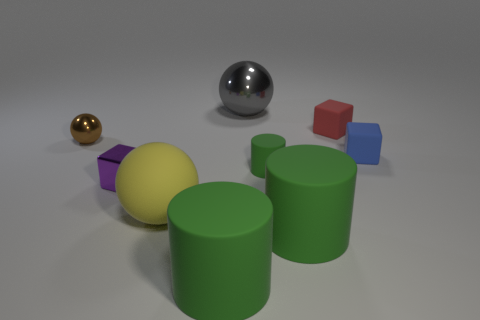Subtract all balls. How many objects are left? 6 Subtract 0 yellow cylinders. How many objects are left? 9 Subtract all gray rubber spheres. Subtract all tiny green objects. How many objects are left? 8 Add 6 red matte things. How many red matte things are left? 7 Add 3 tiny green rubber objects. How many tiny green rubber objects exist? 4 